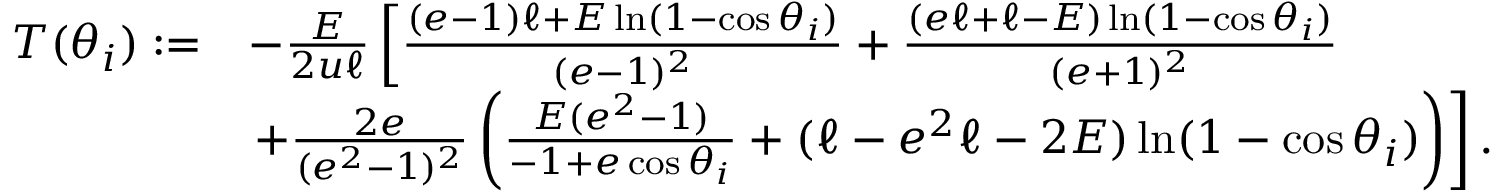Convert formula to latex. <formula><loc_0><loc_0><loc_500><loc_500>\begin{array} { r l } { T ( \theta _ { i } ) \colon = } & { - \frac { E } { 2 u \ell } \left [ \frac { ( e - 1 ) \ell + E \ln ( 1 - \cos \theta _ { i } ) } { ( e - 1 ) ^ { 2 } } + \frac { ( e \ell + \ell - E ) \ln ( 1 - \cos \theta _ { i } ) } { ( e + 1 ) ^ { 2 } } } \\ & { + \frac { 2 e } { ( e ^ { 2 } - 1 ) ^ { 2 } } \left ( \frac { E ( e ^ { 2 } - 1 ) } { - 1 + e \cos \theta _ { i } } + ( \ell - e ^ { 2 } \ell - 2 E ) \ln ( 1 - \cos \theta _ { i } ) \right ) \right ] . } \end{array}</formula> 